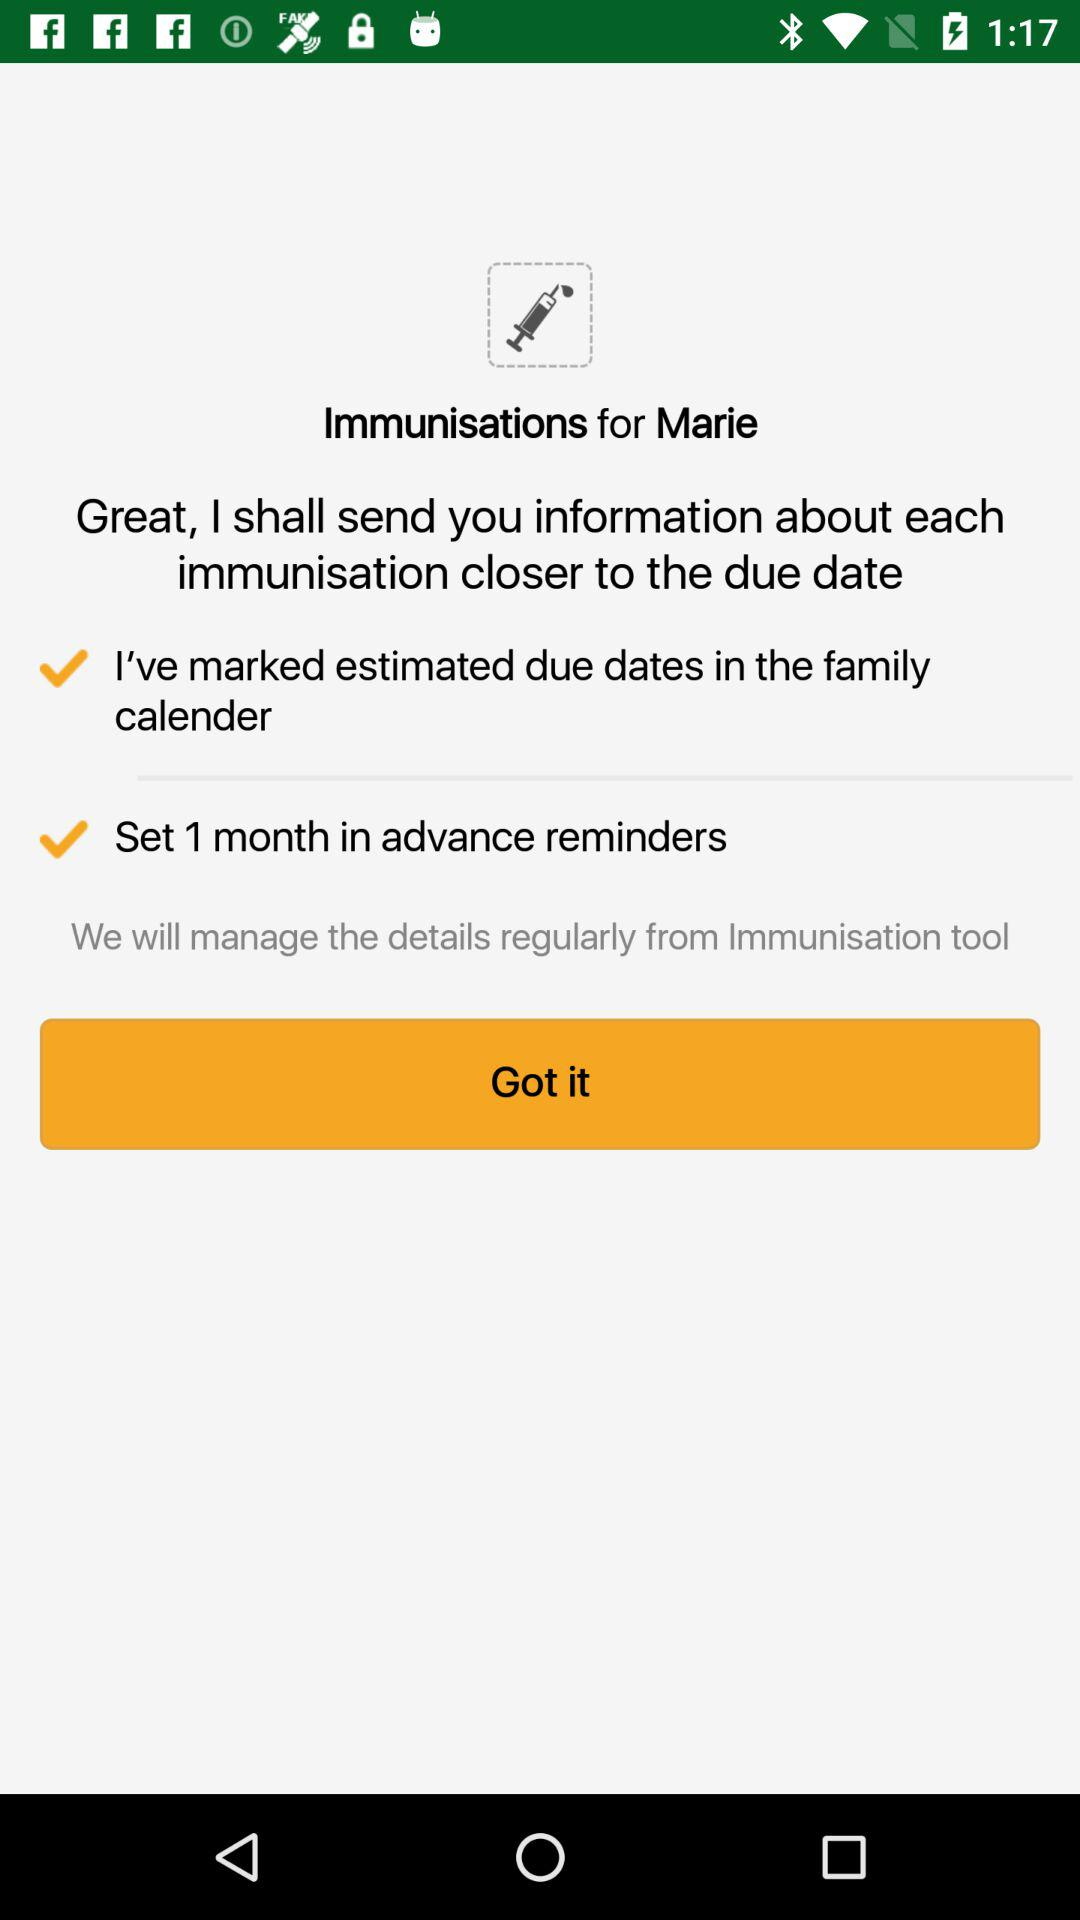What is the app name? The app name is "Immunisations". 